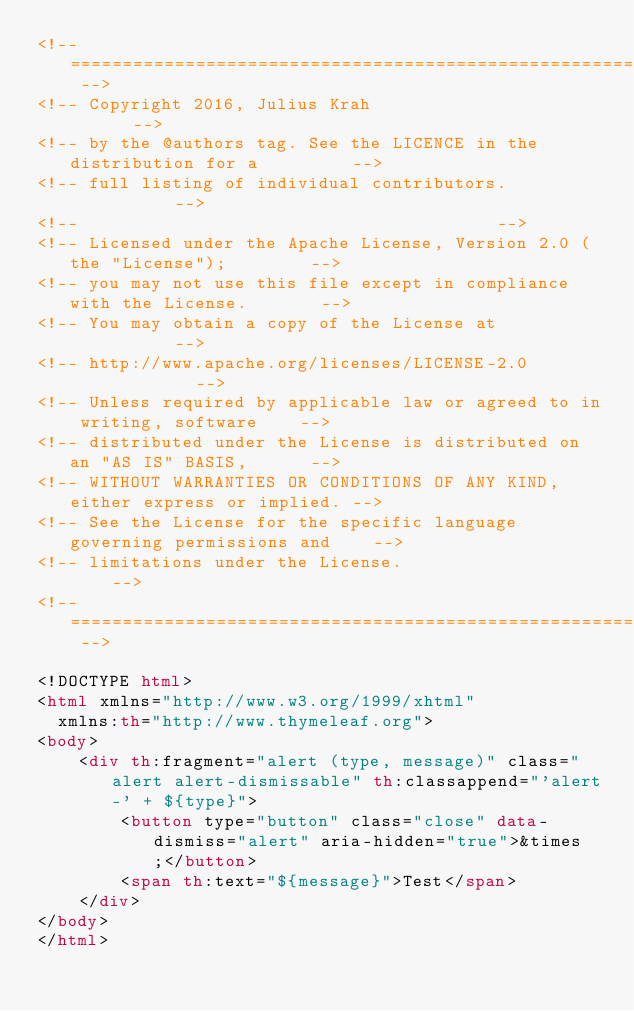Convert code to text. <code><loc_0><loc_0><loc_500><loc_500><_HTML_><!-- ======================================================================== -->
<!-- Copyright 2016, Julius Krah										      -->
<!-- by the @authors tag. See the LICENCE in the distribution for a		      -->
<!-- full listing of individual contributors.							      -->
<!--																	      -->
<!-- Licensed under the Apache License, Version 2.0 (the "License");	      -->
<!-- you may not use this file except in compliance with the License.	      -->
<!-- You may obtain a copy of the License at							      -->
<!-- http://www.apache.org/licenses/LICENSE-2.0							      -->
<!-- Unless required by applicable law or agreed to in writing, software	  -->
<!-- distributed under the License is distributed on an "AS IS" BASIS,		  -->
<!-- WITHOUT WARRANTIES OR CONDITIONS OF ANY KIND, either express or implied. -->
<!-- See the License for the specific language governing permissions and	  -->
<!-- limitations under the License.											  -->
<!-- ======================================================================== -->

<!DOCTYPE html>
<html xmlns="http://www.w3.org/1999/xhtml"
	xmlns:th="http://www.thymeleaf.org">
<body>
    <div th:fragment="alert (type, message)" class="alert alert-dismissable" th:classappend="'alert-' + ${type}">
        <button type="button" class="close" data-dismiss="alert" aria-hidden="true">&times;</button>
        <span th:text="${message}">Test</span>
    </div>
</body>
</html>

</code> 